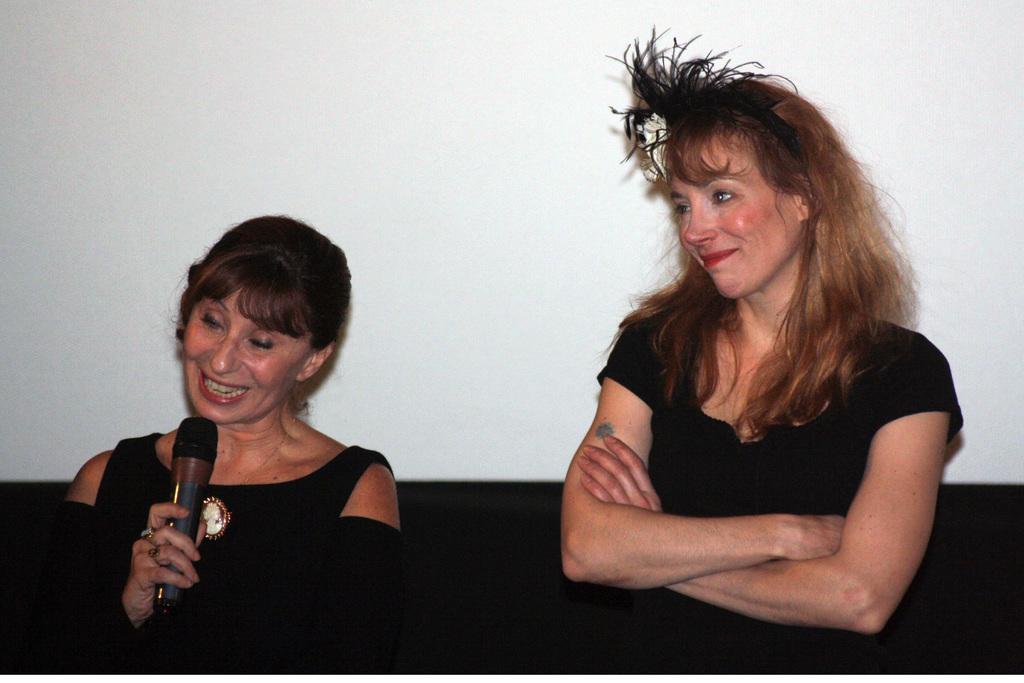Describe this image in one or two sentences. Here a woman is standing and smiling and also another woman is standing and speaking in a microphone along with the smiling face. These two women wear a black color dress. 